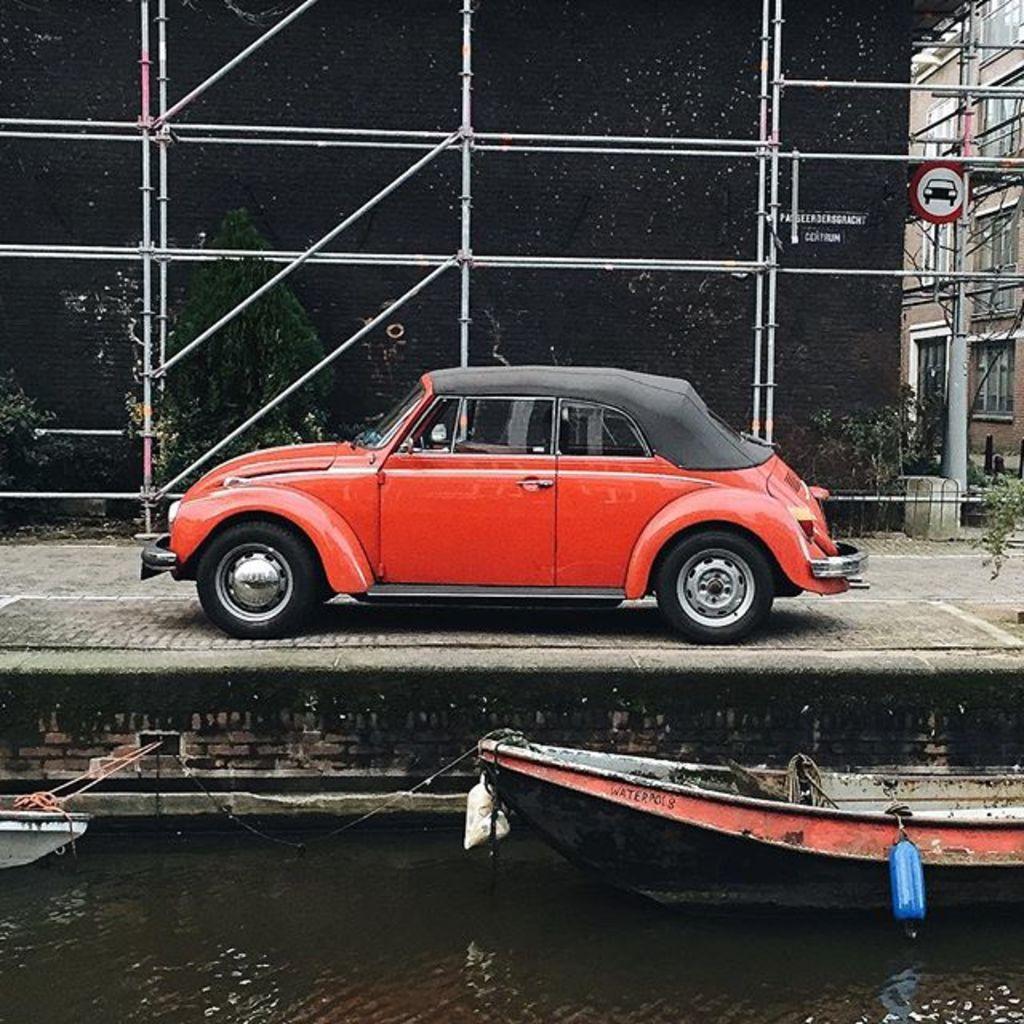Please provide a concise description of this image. In this image there are trees towards the top of the image, there is a building towards the right of the image, there are windows, there are metal poles, there is a red color car on the ground, there is water towards the bottom of the image, there are boats, there is a rope, there are boards, there is text on the board. 